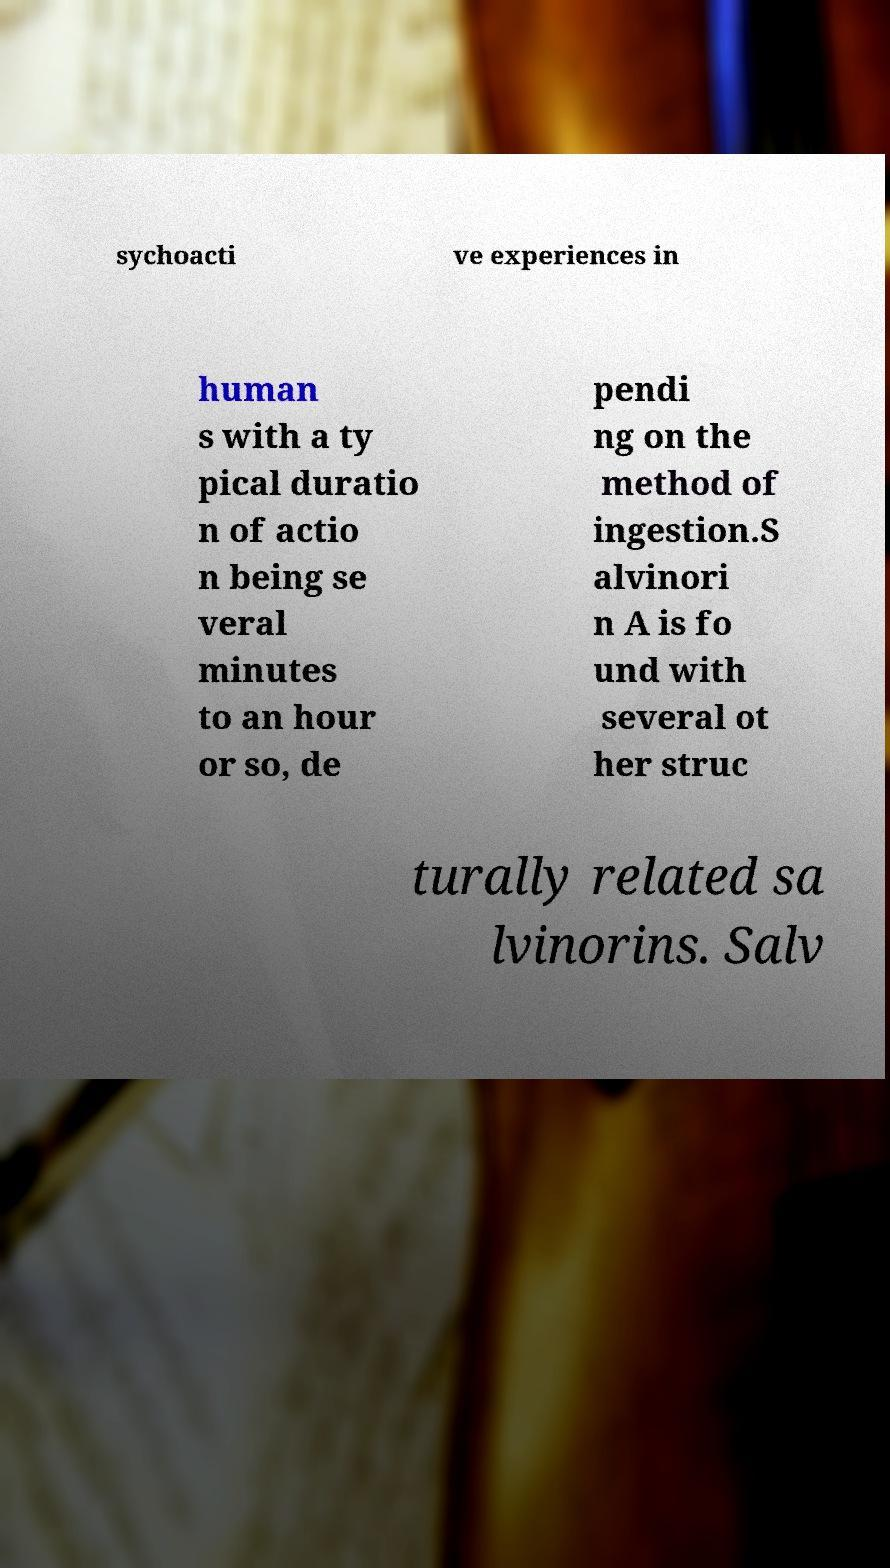Please read and relay the text visible in this image. What does it say? sychoacti ve experiences in human s with a ty pical duratio n of actio n being se veral minutes to an hour or so, de pendi ng on the method of ingestion.S alvinori n A is fo und with several ot her struc turally related sa lvinorins. Salv 